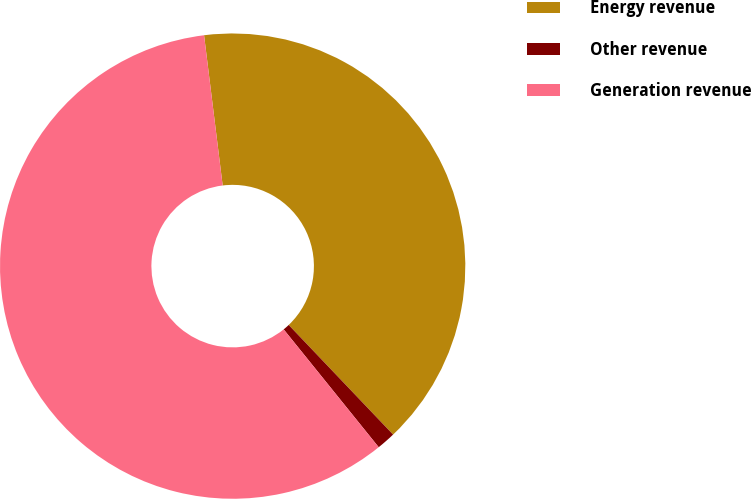<chart> <loc_0><loc_0><loc_500><loc_500><pie_chart><fcel>Energy revenue<fcel>Other revenue<fcel>Generation revenue<nl><fcel>39.85%<fcel>1.31%<fcel>58.84%<nl></chart> 